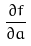<formula> <loc_0><loc_0><loc_500><loc_500>\frac { \partial f } { \partial a }</formula> 